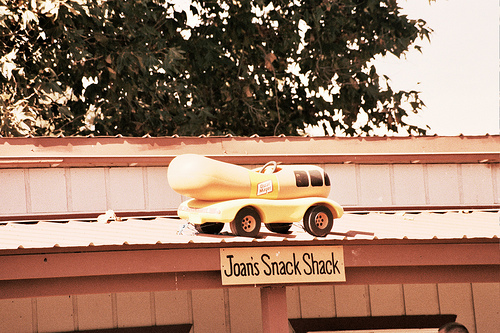<image>
Is there a tree above the sky? No. The tree is not positioned above the sky. The vertical arrangement shows a different relationship. 